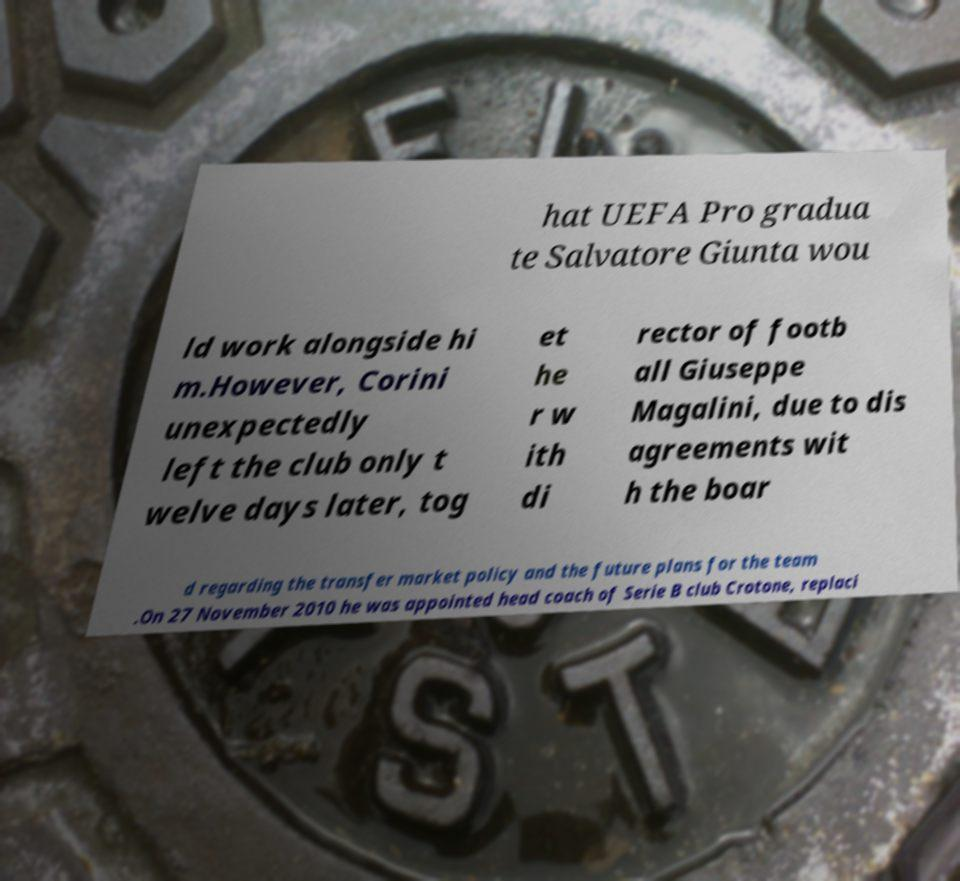What messages or text are displayed in this image? I need them in a readable, typed format. hat UEFA Pro gradua te Salvatore Giunta wou ld work alongside hi m.However, Corini unexpectedly left the club only t welve days later, tog et he r w ith di rector of footb all Giuseppe Magalini, due to dis agreements wit h the boar d regarding the transfer market policy and the future plans for the team .On 27 November 2010 he was appointed head coach of Serie B club Crotone, replaci 